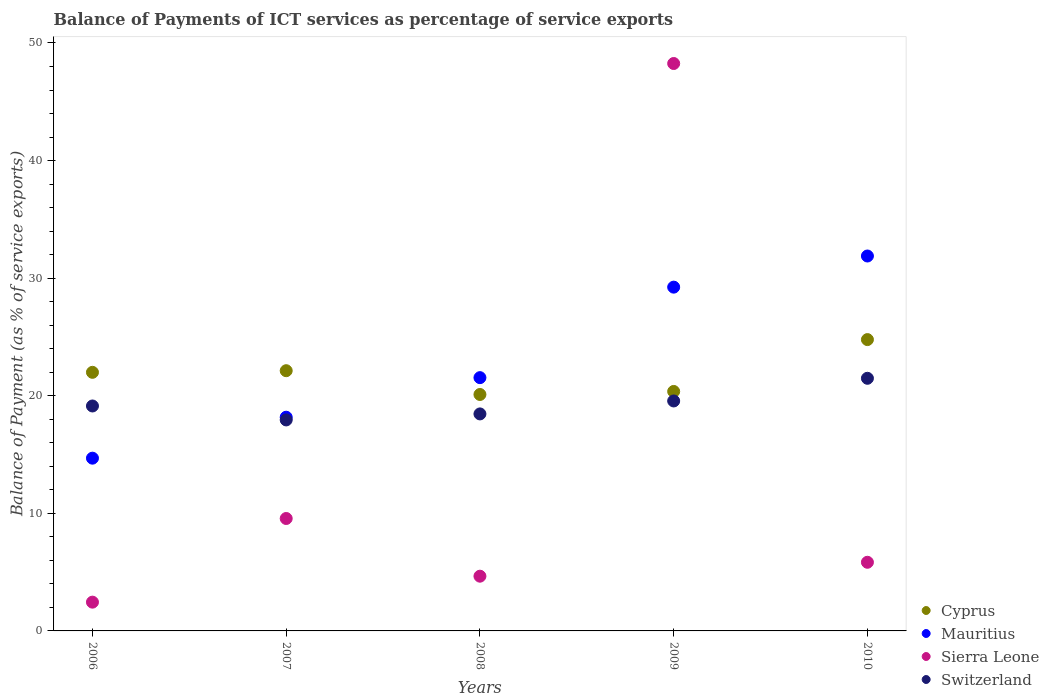What is the balance of payments of ICT services in Cyprus in 2009?
Provide a short and direct response. 20.37. Across all years, what is the maximum balance of payments of ICT services in Mauritius?
Your answer should be compact. 31.88. Across all years, what is the minimum balance of payments of ICT services in Mauritius?
Provide a succinct answer. 14.69. In which year was the balance of payments of ICT services in Switzerland maximum?
Your answer should be compact. 2010. What is the total balance of payments of ICT services in Cyprus in the graph?
Provide a succinct answer. 109.37. What is the difference between the balance of payments of ICT services in Cyprus in 2006 and that in 2010?
Ensure brevity in your answer.  -2.78. What is the difference between the balance of payments of ICT services in Switzerland in 2007 and the balance of payments of ICT services in Cyprus in 2010?
Offer a very short reply. -6.83. What is the average balance of payments of ICT services in Switzerland per year?
Offer a very short reply. 19.31. In the year 2008, what is the difference between the balance of payments of ICT services in Cyprus and balance of payments of ICT services in Mauritius?
Offer a terse response. -1.43. What is the ratio of the balance of payments of ICT services in Cyprus in 2006 to that in 2010?
Offer a terse response. 0.89. What is the difference between the highest and the second highest balance of payments of ICT services in Sierra Leone?
Make the answer very short. 38.69. What is the difference between the highest and the lowest balance of payments of ICT services in Mauritius?
Offer a very short reply. 17.19. In how many years, is the balance of payments of ICT services in Mauritius greater than the average balance of payments of ICT services in Mauritius taken over all years?
Your answer should be very brief. 2. Is the sum of the balance of payments of ICT services in Cyprus in 2007 and 2010 greater than the maximum balance of payments of ICT services in Sierra Leone across all years?
Offer a terse response. No. Is it the case that in every year, the sum of the balance of payments of ICT services in Switzerland and balance of payments of ICT services in Sierra Leone  is greater than the sum of balance of payments of ICT services in Cyprus and balance of payments of ICT services in Mauritius?
Make the answer very short. No. Is it the case that in every year, the sum of the balance of payments of ICT services in Switzerland and balance of payments of ICT services in Cyprus  is greater than the balance of payments of ICT services in Mauritius?
Provide a short and direct response. Yes. Is the balance of payments of ICT services in Cyprus strictly greater than the balance of payments of ICT services in Mauritius over the years?
Keep it short and to the point. No. How many years are there in the graph?
Give a very brief answer. 5. What is the difference between two consecutive major ticks on the Y-axis?
Keep it short and to the point. 10. Does the graph contain any zero values?
Your answer should be compact. No. Where does the legend appear in the graph?
Your answer should be very brief. Bottom right. What is the title of the graph?
Your answer should be compact. Balance of Payments of ICT services as percentage of service exports. Does "St. Lucia" appear as one of the legend labels in the graph?
Ensure brevity in your answer.  No. What is the label or title of the Y-axis?
Your answer should be very brief. Balance of Payment (as % of service exports). What is the Balance of Payment (as % of service exports) of Cyprus in 2006?
Your response must be concise. 21.99. What is the Balance of Payment (as % of service exports) of Mauritius in 2006?
Provide a succinct answer. 14.69. What is the Balance of Payment (as % of service exports) of Sierra Leone in 2006?
Provide a short and direct response. 2.45. What is the Balance of Payment (as % of service exports) of Switzerland in 2006?
Your answer should be very brief. 19.13. What is the Balance of Payment (as % of service exports) of Cyprus in 2007?
Provide a short and direct response. 22.13. What is the Balance of Payment (as % of service exports) in Mauritius in 2007?
Make the answer very short. 18.17. What is the Balance of Payment (as % of service exports) of Sierra Leone in 2007?
Make the answer very short. 9.56. What is the Balance of Payment (as % of service exports) in Switzerland in 2007?
Provide a succinct answer. 17.94. What is the Balance of Payment (as % of service exports) in Cyprus in 2008?
Offer a terse response. 20.11. What is the Balance of Payment (as % of service exports) in Mauritius in 2008?
Your response must be concise. 21.54. What is the Balance of Payment (as % of service exports) of Sierra Leone in 2008?
Offer a very short reply. 4.65. What is the Balance of Payment (as % of service exports) in Switzerland in 2008?
Give a very brief answer. 18.46. What is the Balance of Payment (as % of service exports) of Cyprus in 2009?
Your answer should be compact. 20.37. What is the Balance of Payment (as % of service exports) in Mauritius in 2009?
Your answer should be compact. 29.24. What is the Balance of Payment (as % of service exports) in Sierra Leone in 2009?
Keep it short and to the point. 48.26. What is the Balance of Payment (as % of service exports) of Switzerland in 2009?
Offer a terse response. 19.56. What is the Balance of Payment (as % of service exports) in Cyprus in 2010?
Keep it short and to the point. 24.78. What is the Balance of Payment (as % of service exports) of Mauritius in 2010?
Your answer should be very brief. 31.88. What is the Balance of Payment (as % of service exports) in Sierra Leone in 2010?
Make the answer very short. 5.84. What is the Balance of Payment (as % of service exports) of Switzerland in 2010?
Offer a terse response. 21.48. Across all years, what is the maximum Balance of Payment (as % of service exports) of Cyprus?
Your answer should be very brief. 24.78. Across all years, what is the maximum Balance of Payment (as % of service exports) in Mauritius?
Your answer should be compact. 31.88. Across all years, what is the maximum Balance of Payment (as % of service exports) in Sierra Leone?
Keep it short and to the point. 48.26. Across all years, what is the maximum Balance of Payment (as % of service exports) of Switzerland?
Make the answer very short. 21.48. Across all years, what is the minimum Balance of Payment (as % of service exports) in Cyprus?
Make the answer very short. 20.11. Across all years, what is the minimum Balance of Payment (as % of service exports) in Mauritius?
Provide a succinct answer. 14.69. Across all years, what is the minimum Balance of Payment (as % of service exports) in Sierra Leone?
Make the answer very short. 2.45. Across all years, what is the minimum Balance of Payment (as % of service exports) in Switzerland?
Your response must be concise. 17.94. What is the total Balance of Payment (as % of service exports) in Cyprus in the graph?
Give a very brief answer. 109.37. What is the total Balance of Payment (as % of service exports) in Mauritius in the graph?
Keep it short and to the point. 115.53. What is the total Balance of Payment (as % of service exports) of Sierra Leone in the graph?
Make the answer very short. 70.76. What is the total Balance of Payment (as % of service exports) of Switzerland in the graph?
Your answer should be compact. 96.57. What is the difference between the Balance of Payment (as % of service exports) of Cyprus in 2006 and that in 2007?
Offer a terse response. -0.14. What is the difference between the Balance of Payment (as % of service exports) of Mauritius in 2006 and that in 2007?
Offer a very short reply. -3.48. What is the difference between the Balance of Payment (as % of service exports) in Sierra Leone in 2006 and that in 2007?
Your answer should be very brief. -7.11. What is the difference between the Balance of Payment (as % of service exports) of Switzerland in 2006 and that in 2007?
Make the answer very short. 1.19. What is the difference between the Balance of Payment (as % of service exports) in Cyprus in 2006 and that in 2008?
Ensure brevity in your answer.  1.88. What is the difference between the Balance of Payment (as % of service exports) in Mauritius in 2006 and that in 2008?
Offer a very short reply. -6.85. What is the difference between the Balance of Payment (as % of service exports) of Sierra Leone in 2006 and that in 2008?
Give a very brief answer. -2.21. What is the difference between the Balance of Payment (as % of service exports) of Switzerland in 2006 and that in 2008?
Give a very brief answer. 0.67. What is the difference between the Balance of Payment (as % of service exports) of Cyprus in 2006 and that in 2009?
Ensure brevity in your answer.  1.63. What is the difference between the Balance of Payment (as % of service exports) in Mauritius in 2006 and that in 2009?
Make the answer very short. -14.54. What is the difference between the Balance of Payment (as % of service exports) of Sierra Leone in 2006 and that in 2009?
Your response must be concise. -45.81. What is the difference between the Balance of Payment (as % of service exports) in Switzerland in 2006 and that in 2009?
Your answer should be very brief. -0.43. What is the difference between the Balance of Payment (as % of service exports) in Cyprus in 2006 and that in 2010?
Your answer should be compact. -2.78. What is the difference between the Balance of Payment (as % of service exports) of Mauritius in 2006 and that in 2010?
Your answer should be compact. -17.19. What is the difference between the Balance of Payment (as % of service exports) of Sierra Leone in 2006 and that in 2010?
Your answer should be compact. -3.39. What is the difference between the Balance of Payment (as % of service exports) of Switzerland in 2006 and that in 2010?
Offer a very short reply. -2.36. What is the difference between the Balance of Payment (as % of service exports) of Cyprus in 2007 and that in 2008?
Offer a terse response. 2.02. What is the difference between the Balance of Payment (as % of service exports) in Mauritius in 2007 and that in 2008?
Offer a terse response. -3.37. What is the difference between the Balance of Payment (as % of service exports) in Sierra Leone in 2007 and that in 2008?
Make the answer very short. 4.91. What is the difference between the Balance of Payment (as % of service exports) in Switzerland in 2007 and that in 2008?
Offer a very short reply. -0.51. What is the difference between the Balance of Payment (as % of service exports) in Cyprus in 2007 and that in 2009?
Your answer should be compact. 1.76. What is the difference between the Balance of Payment (as % of service exports) of Mauritius in 2007 and that in 2009?
Provide a succinct answer. -11.06. What is the difference between the Balance of Payment (as % of service exports) in Sierra Leone in 2007 and that in 2009?
Offer a very short reply. -38.69. What is the difference between the Balance of Payment (as % of service exports) in Switzerland in 2007 and that in 2009?
Make the answer very short. -1.61. What is the difference between the Balance of Payment (as % of service exports) of Cyprus in 2007 and that in 2010?
Keep it short and to the point. -2.65. What is the difference between the Balance of Payment (as % of service exports) in Mauritius in 2007 and that in 2010?
Offer a terse response. -13.71. What is the difference between the Balance of Payment (as % of service exports) of Sierra Leone in 2007 and that in 2010?
Provide a succinct answer. 3.72. What is the difference between the Balance of Payment (as % of service exports) of Switzerland in 2007 and that in 2010?
Your response must be concise. -3.54. What is the difference between the Balance of Payment (as % of service exports) in Cyprus in 2008 and that in 2009?
Ensure brevity in your answer.  -0.26. What is the difference between the Balance of Payment (as % of service exports) in Mauritius in 2008 and that in 2009?
Your response must be concise. -7.7. What is the difference between the Balance of Payment (as % of service exports) of Sierra Leone in 2008 and that in 2009?
Provide a succinct answer. -43.6. What is the difference between the Balance of Payment (as % of service exports) of Switzerland in 2008 and that in 2009?
Provide a succinct answer. -1.1. What is the difference between the Balance of Payment (as % of service exports) of Cyprus in 2008 and that in 2010?
Offer a terse response. -4.67. What is the difference between the Balance of Payment (as % of service exports) in Mauritius in 2008 and that in 2010?
Your answer should be compact. -10.34. What is the difference between the Balance of Payment (as % of service exports) of Sierra Leone in 2008 and that in 2010?
Offer a very short reply. -1.18. What is the difference between the Balance of Payment (as % of service exports) of Switzerland in 2008 and that in 2010?
Make the answer very short. -3.03. What is the difference between the Balance of Payment (as % of service exports) of Cyprus in 2009 and that in 2010?
Provide a short and direct response. -4.41. What is the difference between the Balance of Payment (as % of service exports) in Mauritius in 2009 and that in 2010?
Provide a short and direct response. -2.65. What is the difference between the Balance of Payment (as % of service exports) of Sierra Leone in 2009 and that in 2010?
Offer a terse response. 42.42. What is the difference between the Balance of Payment (as % of service exports) of Switzerland in 2009 and that in 2010?
Your answer should be very brief. -1.93. What is the difference between the Balance of Payment (as % of service exports) of Cyprus in 2006 and the Balance of Payment (as % of service exports) of Mauritius in 2007?
Offer a very short reply. 3.82. What is the difference between the Balance of Payment (as % of service exports) of Cyprus in 2006 and the Balance of Payment (as % of service exports) of Sierra Leone in 2007?
Make the answer very short. 12.43. What is the difference between the Balance of Payment (as % of service exports) in Cyprus in 2006 and the Balance of Payment (as % of service exports) in Switzerland in 2007?
Offer a very short reply. 4.05. What is the difference between the Balance of Payment (as % of service exports) of Mauritius in 2006 and the Balance of Payment (as % of service exports) of Sierra Leone in 2007?
Give a very brief answer. 5.13. What is the difference between the Balance of Payment (as % of service exports) of Mauritius in 2006 and the Balance of Payment (as % of service exports) of Switzerland in 2007?
Keep it short and to the point. -3.25. What is the difference between the Balance of Payment (as % of service exports) in Sierra Leone in 2006 and the Balance of Payment (as % of service exports) in Switzerland in 2007?
Your response must be concise. -15.5. What is the difference between the Balance of Payment (as % of service exports) in Cyprus in 2006 and the Balance of Payment (as % of service exports) in Mauritius in 2008?
Your answer should be compact. 0.45. What is the difference between the Balance of Payment (as % of service exports) of Cyprus in 2006 and the Balance of Payment (as % of service exports) of Sierra Leone in 2008?
Your answer should be compact. 17.34. What is the difference between the Balance of Payment (as % of service exports) of Cyprus in 2006 and the Balance of Payment (as % of service exports) of Switzerland in 2008?
Your answer should be very brief. 3.54. What is the difference between the Balance of Payment (as % of service exports) in Mauritius in 2006 and the Balance of Payment (as % of service exports) in Sierra Leone in 2008?
Keep it short and to the point. 10.04. What is the difference between the Balance of Payment (as % of service exports) in Mauritius in 2006 and the Balance of Payment (as % of service exports) in Switzerland in 2008?
Offer a terse response. -3.76. What is the difference between the Balance of Payment (as % of service exports) of Sierra Leone in 2006 and the Balance of Payment (as % of service exports) of Switzerland in 2008?
Your answer should be very brief. -16.01. What is the difference between the Balance of Payment (as % of service exports) in Cyprus in 2006 and the Balance of Payment (as % of service exports) in Mauritius in 2009?
Ensure brevity in your answer.  -7.24. What is the difference between the Balance of Payment (as % of service exports) in Cyprus in 2006 and the Balance of Payment (as % of service exports) in Sierra Leone in 2009?
Offer a very short reply. -26.26. What is the difference between the Balance of Payment (as % of service exports) in Cyprus in 2006 and the Balance of Payment (as % of service exports) in Switzerland in 2009?
Provide a succinct answer. 2.43. What is the difference between the Balance of Payment (as % of service exports) of Mauritius in 2006 and the Balance of Payment (as % of service exports) of Sierra Leone in 2009?
Offer a terse response. -33.56. What is the difference between the Balance of Payment (as % of service exports) in Mauritius in 2006 and the Balance of Payment (as % of service exports) in Switzerland in 2009?
Your answer should be compact. -4.87. What is the difference between the Balance of Payment (as % of service exports) of Sierra Leone in 2006 and the Balance of Payment (as % of service exports) of Switzerland in 2009?
Your response must be concise. -17.11. What is the difference between the Balance of Payment (as % of service exports) of Cyprus in 2006 and the Balance of Payment (as % of service exports) of Mauritius in 2010?
Offer a terse response. -9.89. What is the difference between the Balance of Payment (as % of service exports) of Cyprus in 2006 and the Balance of Payment (as % of service exports) of Sierra Leone in 2010?
Provide a short and direct response. 16.15. What is the difference between the Balance of Payment (as % of service exports) of Cyprus in 2006 and the Balance of Payment (as % of service exports) of Switzerland in 2010?
Your response must be concise. 0.51. What is the difference between the Balance of Payment (as % of service exports) in Mauritius in 2006 and the Balance of Payment (as % of service exports) in Sierra Leone in 2010?
Ensure brevity in your answer.  8.85. What is the difference between the Balance of Payment (as % of service exports) in Mauritius in 2006 and the Balance of Payment (as % of service exports) in Switzerland in 2010?
Make the answer very short. -6.79. What is the difference between the Balance of Payment (as % of service exports) of Sierra Leone in 2006 and the Balance of Payment (as % of service exports) of Switzerland in 2010?
Your response must be concise. -19.04. What is the difference between the Balance of Payment (as % of service exports) of Cyprus in 2007 and the Balance of Payment (as % of service exports) of Mauritius in 2008?
Your answer should be very brief. 0.59. What is the difference between the Balance of Payment (as % of service exports) in Cyprus in 2007 and the Balance of Payment (as % of service exports) in Sierra Leone in 2008?
Your response must be concise. 17.48. What is the difference between the Balance of Payment (as % of service exports) of Cyprus in 2007 and the Balance of Payment (as % of service exports) of Switzerland in 2008?
Give a very brief answer. 3.67. What is the difference between the Balance of Payment (as % of service exports) in Mauritius in 2007 and the Balance of Payment (as % of service exports) in Sierra Leone in 2008?
Give a very brief answer. 13.52. What is the difference between the Balance of Payment (as % of service exports) of Mauritius in 2007 and the Balance of Payment (as % of service exports) of Switzerland in 2008?
Offer a terse response. -0.28. What is the difference between the Balance of Payment (as % of service exports) in Sierra Leone in 2007 and the Balance of Payment (as % of service exports) in Switzerland in 2008?
Ensure brevity in your answer.  -8.89. What is the difference between the Balance of Payment (as % of service exports) in Cyprus in 2007 and the Balance of Payment (as % of service exports) in Mauritius in 2009?
Ensure brevity in your answer.  -7.11. What is the difference between the Balance of Payment (as % of service exports) of Cyprus in 2007 and the Balance of Payment (as % of service exports) of Sierra Leone in 2009?
Make the answer very short. -26.13. What is the difference between the Balance of Payment (as % of service exports) in Cyprus in 2007 and the Balance of Payment (as % of service exports) in Switzerland in 2009?
Make the answer very short. 2.57. What is the difference between the Balance of Payment (as % of service exports) in Mauritius in 2007 and the Balance of Payment (as % of service exports) in Sierra Leone in 2009?
Ensure brevity in your answer.  -30.08. What is the difference between the Balance of Payment (as % of service exports) in Mauritius in 2007 and the Balance of Payment (as % of service exports) in Switzerland in 2009?
Your answer should be compact. -1.38. What is the difference between the Balance of Payment (as % of service exports) of Sierra Leone in 2007 and the Balance of Payment (as % of service exports) of Switzerland in 2009?
Make the answer very short. -10. What is the difference between the Balance of Payment (as % of service exports) in Cyprus in 2007 and the Balance of Payment (as % of service exports) in Mauritius in 2010?
Offer a terse response. -9.75. What is the difference between the Balance of Payment (as % of service exports) of Cyprus in 2007 and the Balance of Payment (as % of service exports) of Sierra Leone in 2010?
Offer a very short reply. 16.29. What is the difference between the Balance of Payment (as % of service exports) of Cyprus in 2007 and the Balance of Payment (as % of service exports) of Switzerland in 2010?
Give a very brief answer. 0.65. What is the difference between the Balance of Payment (as % of service exports) in Mauritius in 2007 and the Balance of Payment (as % of service exports) in Sierra Leone in 2010?
Ensure brevity in your answer.  12.34. What is the difference between the Balance of Payment (as % of service exports) of Mauritius in 2007 and the Balance of Payment (as % of service exports) of Switzerland in 2010?
Your answer should be very brief. -3.31. What is the difference between the Balance of Payment (as % of service exports) in Sierra Leone in 2007 and the Balance of Payment (as % of service exports) in Switzerland in 2010?
Provide a succinct answer. -11.92. What is the difference between the Balance of Payment (as % of service exports) of Cyprus in 2008 and the Balance of Payment (as % of service exports) of Mauritius in 2009?
Provide a succinct answer. -9.13. What is the difference between the Balance of Payment (as % of service exports) of Cyprus in 2008 and the Balance of Payment (as % of service exports) of Sierra Leone in 2009?
Make the answer very short. -28.15. What is the difference between the Balance of Payment (as % of service exports) of Cyprus in 2008 and the Balance of Payment (as % of service exports) of Switzerland in 2009?
Provide a succinct answer. 0.55. What is the difference between the Balance of Payment (as % of service exports) in Mauritius in 2008 and the Balance of Payment (as % of service exports) in Sierra Leone in 2009?
Make the answer very short. -26.72. What is the difference between the Balance of Payment (as % of service exports) in Mauritius in 2008 and the Balance of Payment (as % of service exports) in Switzerland in 2009?
Provide a succinct answer. 1.98. What is the difference between the Balance of Payment (as % of service exports) of Sierra Leone in 2008 and the Balance of Payment (as % of service exports) of Switzerland in 2009?
Your response must be concise. -14.9. What is the difference between the Balance of Payment (as % of service exports) of Cyprus in 2008 and the Balance of Payment (as % of service exports) of Mauritius in 2010?
Provide a short and direct response. -11.78. What is the difference between the Balance of Payment (as % of service exports) in Cyprus in 2008 and the Balance of Payment (as % of service exports) in Sierra Leone in 2010?
Offer a very short reply. 14.27. What is the difference between the Balance of Payment (as % of service exports) in Cyprus in 2008 and the Balance of Payment (as % of service exports) in Switzerland in 2010?
Your answer should be compact. -1.38. What is the difference between the Balance of Payment (as % of service exports) of Mauritius in 2008 and the Balance of Payment (as % of service exports) of Sierra Leone in 2010?
Offer a terse response. 15.7. What is the difference between the Balance of Payment (as % of service exports) in Mauritius in 2008 and the Balance of Payment (as % of service exports) in Switzerland in 2010?
Offer a terse response. 0.05. What is the difference between the Balance of Payment (as % of service exports) of Sierra Leone in 2008 and the Balance of Payment (as % of service exports) of Switzerland in 2010?
Your answer should be very brief. -16.83. What is the difference between the Balance of Payment (as % of service exports) in Cyprus in 2009 and the Balance of Payment (as % of service exports) in Mauritius in 2010?
Offer a terse response. -11.52. What is the difference between the Balance of Payment (as % of service exports) of Cyprus in 2009 and the Balance of Payment (as % of service exports) of Sierra Leone in 2010?
Offer a very short reply. 14.53. What is the difference between the Balance of Payment (as % of service exports) of Cyprus in 2009 and the Balance of Payment (as % of service exports) of Switzerland in 2010?
Ensure brevity in your answer.  -1.12. What is the difference between the Balance of Payment (as % of service exports) in Mauritius in 2009 and the Balance of Payment (as % of service exports) in Sierra Leone in 2010?
Your answer should be very brief. 23.4. What is the difference between the Balance of Payment (as % of service exports) in Mauritius in 2009 and the Balance of Payment (as % of service exports) in Switzerland in 2010?
Keep it short and to the point. 7.75. What is the difference between the Balance of Payment (as % of service exports) in Sierra Leone in 2009 and the Balance of Payment (as % of service exports) in Switzerland in 2010?
Give a very brief answer. 26.77. What is the average Balance of Payment (as % of service exports) in Cyprus per year?
Your answer should be very brief. 21.87. What is the average Balance of Payment (as % of service exports) in Mauritius per year?
Make the answer very short. 23.11. What is the average Balance of Payment (as % of service exports) of Sierra Leone per year?
Offer a very short reply. 14.15. What is the average Balance of Payment (as % of service exports) in Switzerland per year?
Your answer should be very brief. 19.31. In the year 2006, what is the difference between the Balance of Payment (as % of service exports) in Cyprus and Balance of Payment (as % of service exports) in Mauritius?
Ensure brevity in your answer.  7.3. In the year 2006, what is the difference between the Balance of Payment (as % of service exports) of Cyprus and Balance of Payment (as % of service exports) of Sierra Leone?
Make the answer very short. 19.55. In the year 2006, what is the difference between the Balance of Payment (as % of service exports) of Cyprus and Balance of Payment (as % of service exports) of Switzerland?
Provide a succinct answer. 2.86. In the year 2006, what is the difference between the Balance of Payment (as % of service exports) in Mauritius and Balance of Payment (as % of service exports) in Sierra Leone?
Make the answer very short. 12.24. In the year 2006, what is the difference between the Balance of Payment (as % of service exports) of Mauritius and Balance of Payment (as % of service exports) of Switzerland?
Make the answer very short. -4.44. In the year 2006, what is the difference between the Balance of Payment (as % of service exports) of Sierra Leone and Balance of Payment (as % of service exports) of Switzerland?
Your answer should be compact. -16.68. In the year 2007, what is the difference between the Balance of Payment (as % of service exports) of Cyprus and Balance of Payment (as % of service exports) of Mauritius?
Your response must be concise. 3.96. In the year 2007, what is the difference between the Balance of Payment (as % of service exports) in Cyprus and Balance of Payment (as % of service exports) in Sierra Leone?
Keep it short and to the point. 12.57. In the year 2007, what is the difference between the Balance of Payment (as % of service exports) in Cyprus and Balance of Payment (as % of service exports) in Switzerland?
Make the answer very short. 4.19. In the year 2007, what is the difference between the Balance of Payment (as % of service exports) in Mauritius and Balance of Payment (as % of service exports) in Sierra Leone?
Offer a terse response. 8.61. In the year 2007, what is the difference between the Balance of Payment (as % of service exports) in Mauritius and Balance of Payment (as % of service exports) in Switzerland?
Give a very brief answer. 0.23. In the year 2007, what is the difference between the Balance of Payment (as % of service exports) in Sierra Leone and Balance of Payment (as % of service exports) in Switzerland?
Offer a terse response. -8.38. In the year 2008, what is the difference between the Balance of Payment (as % of service exports) of Cyprus and Balance of Payment (as % of service exports) of Mauritius?
Provide a succinct answer. -1.43. In the year 2008, what is the difference between the Balance of Payment (as % of service exports) of Cyprus and Balance of Payment (as % of service exports) of Sierra Leone?
Keep it short and to the point. 15.45. In the year 2008, what is the difference between the Balance of Payment (as % of service exports) of Cyprus and Balance of Payment (as % of service exports) of Switzerland?
Give a very brief answer. 1.65. In the year 2008, what is the difference between the Balance of Payment (as % of service exports) of Mauritius and Balance of Payment (as % of service exports) of Sierra Leone?
Offer a very short reply. 16.89. In the year 2008, what is the difference between the Balance of Payment (as % of service exports) in Mauritius and Balance of Payment (as % of service exports) in Switzerland?
Give a very brief answer. 3.08. In the year 2008, what is the difference between the Balance of Payment (as % of service exports) in Sierra Leone and Balance of Payment (as % of service exports) in Switzerland?
Ensure brevity in your answer.  -13.8. In the year 2009, what is the difference between the Balance of Payment (as % of service exports) in Cyprus and Balance of Payment (as % of service exports) in Mauritius?
Your response must be concise. -8.87. In the year 2009, what is the difference between the Balance of Payment (as % of service exports) in Cyprus and Balance of Payment (as % of service exports) in Sierra Leone?
Offer a very short reply. -27.89. In the year 2009, what is the difference between the Balance of Payment (as % of service exports) of Cyprus and Balance of Payment (as % of service exports) of Switzerland?
Make the answer very short. 0.81. In the year 2009, what is the difference between the Balance of Payment (as % of service exports) of Mauritius and Balance of Payment (as % of service exports) of Sierra Leone?
Keep it short and to the point. -19.02. In the year 2009, what is the difference between the Balance of Payment (as % of service exports) of Mauritius and Balance of Payment (as % of service exports) of Switzerland?
Your answer should be compact. 9.68. In the year 2009, what is the difference between the Balance of Payment (as % of service exports) of Sierra Leone and Balance of Payment (as % of service exports) of Switzerland?
Make the answer very short. 28.7. In the year 2010, what is the difference between the Balance of Payment (as % of service exports) of Cyprus and Balance of Payment (as % of service exports) of Mauritius?
Ensure brevity in your answer.  -7.11. In the year 2010, what is the difference between the Balance of Payment (as % of service exports) in Cyprus and Balance of Payment (as % of service exports) in Sierra Leone?
Your answer should be compact. 18.94. In the year 2010, what is the difference between the Balance of Payment (as % of service exports) of Cyprus and Balance of Payment (as % of service exports) of Switzerland?
Offer a terse response. 3.29. In the year 2010, what is the difference between the Balance of Payment (as % of service exports) of Mauritius and Balance of Payment (as % of service exports) of Sierra Leone?
Provide a short and direct response. 26.05. In the year 2010, what is the difference between the Balance of Payment (as % of service exports) in Mauritius and Balance of Payment (as % of service exports) in Switzerland?
Your response must be concise. 10.4. In the year 2010, what is the difference between the Balance of Payment (as % of service exports) in Sierra Leone and Balance of Payment (as % of service exports) in Switzerland?
Your answer should be very brief. -15.65. What is the ratio of the Balance of Payment (as % of service exports) in Cyprus in 2006 to that in 2007?
Provide a succinct answer. 0.99. What is the ratio of the Balance of Payment (as % of service exports) in Mauritius in 2006 to that in 2007?
Provide a short and direct response. 0.81. What is the ratio of the Balance of Payment (as % of service exports) of Sierra Leone in 2006 to that in 2007?
Give a very brief answer. 0.26. What is the ratio of the Balance of Payment (as % of service exports) of Switzerland in 2006 to that in 2007?
Offer a very short reply. 1.07. What is the ratio of the Balance of Payment (as % of service exports) of Cyprus in 2006 to that in 2008?
Offer a terse response. 1.09. What is the ratio of the Balance of Payment (as % of service exports) of Mauritius in 2006 to that in 2008?
Provide a short and direct response. 0.68. What is the ratio of the Balance of Payment (as % of service exports) in Sierra Leone in 2006 to that in 2008?
Your answer should be compact. 0.53. What is the ratio of the Balance of Payment (as % of service exports) in Switzerland in 2006 to that in 2008?
Offer a terse response. 1.04. What is the ratio of the Balance of Payment (as % of service exports) in Cyprus in 2006 to that in 2009?
Ensure brevity in your answer.  1.08. What is the ratio of the Balance of Payment (as % of service exports) in Mauritius in 2006 to that in 2009?
Your response must be concise. 0.5. What is the ratio of the Balance of Payment (as % of service exports) of Sierra Leone in 2006 to that in 2009?
Ensure brevity in your answer.  0.05. What is the ratio of the Balance of Payment (as % of service exports) of Switzerland in 2006 to that in 2009?
Offer a very short reply. 0.98. What is the ratio of the Balance of Payment (as % of service exports) of Cyprus in 2006 to that in 2010?
Your answer should be compact. 0.89. What is the ratio of the Balance of Payment (as % of service exports) in Mauritius in 2006 to that in 2010?
Provide a succinct answer. 0.46. What is the ratio of the Balance of Payment (as % of service exports) of Sierra Leone in 2006 to that in 2010?
Offer a terse response. 0.42. What is the ratio of the Balance of Payment (as % of service exports) of Switzerland in 2006 to that in 2010?
Provide a short and direct response. 0.89. What is the ratio of the Balance of Payment (as % of service exports) in Cyprus in 2007 to that in 2008?
Your response must be concise. 1.1. What is the ratio of the Balance of Payment (as % of service exports) in Mauritius in 2007 to that in 2008?
Your response must be concise. 0.84. What is the ratio of the Balance of Payment (as % of service exports) of Sierra Leone in 2007 to that in 2008?
Offer a very short reply. 2.05. What is the ratio of the Balance of Payment (as % of service exports) of Switzerland in 2007 to that in 2008?
Your answer should be very brief. 0.97. What is the ratio of the Balance of Payment (as % of service exports) of Cyprus in 2007 to that in 2009?
Your response must be concise. 1.09. What is the ratio of the Balance of Payment (as % of service exports) in Mauritius in 2007 to that in 2009?
Your answer should be compact. 0.62. What is the ratio of the Balance of Payment (as % of service exports) in Sierra Leone in 2007 to that in 2009?
Your answer should be very brief. 0.2. What is the ratio of the Balance of Payment (as % of service exports) of Switzerland in 2007 to that in 2009?
Provide a short and direct response. 0.92. What is the ratio of the Balance of Payment (as % of service exports) of Cyprus in 2007 to that in 2010?
Give a very brief answer. 0.89. What is the ratio of the Balance of Payment (as % of service exports) in Mauritius in 2007 to that in 2010?
Your answer should be very brief. 0.57. What is the ratio of the Balance of Payment (as % of service exports) of Sierra Leone in 2007 to that in 2010?
Give a very brief answer. 1.64. What is the ratio of the Balance of Payment (as % of service exports) in Switzerland in 2007 to that in 2010?
Provide a succinct answer. 0.84. What is the ratio of the Balance of Payment (as % of service exports) in Cyprus in 2008 to that in 2009?
Keep it short and to the point. 0.99. What is the ratio of the Balance of Payment (as % of service exports) of Mauritius in 2008 to that in 2009?
Your answer should be very brief. 0.74. What is the ratio of the Balance of Payment (as % of service exports) in Sierra Leone in 2008 to that in 2009?
Ensure brevity in your answer.  0.1. What is the ratio of the Balance of Payment (as % of service exports) in Switzerland in 2008 to that in 2009?
Give a very brief answer. 0.94. What is the ratio of the Balance of Payment (as % of service exports) of Cyprus in 2008 to that in 2010?
Offer a terse response. 0.81. What is the ratio of the Balance of Payment (as % of service exports) in Mauritius in 2008 to that in 2010?
Offer a terse response. 0.68. What is the ratio of the Balance of Payment (as % of service exports) of Sierra Leone in 2008 to that in 2010?
Make the answer very short. 0.8. What is the ratio of the Balance of Payment (as % of service exports) of Switzerland in 2008 to that in 2010?
Your response must be concise. 0.86. What is the ratio of the Balance of Payment (as % of service exports) in Cyprus in 2009 to that in 2010?
Ensure brevity in your answer.  0.82. What is the ratio of the Balance of Payment (as % of service exports) of Mauritius in 2009 to that in 2010?
Give a very brief answer. 0.92. What is the ratio of the Balance of Payment (as % of service exports) in Sierra Leone in 2009 to that in 2010?
Make the answer very short. 8.27. What is the ratio of the Balance of Payment (as % of service exports) of Switzerland in 2009 to that in 2010?
Your response must be concise. 0.91. What is the difference between the highest and the second highest Balance of Payment (as % of service exports) in Cyprus?
Offer a terse response. 2.65. What is the difference between the highest and the second highest Balance of Payment (as % of service exports) of Mauritius?
Provide a short and direct response. 2.65. What is the difference between the highest and the second highest Balance of Payment (as % of service exports) of Sierra Leone?
Give a very brief answer. 38.69. What is the difference between the highest and the second highest Balance of Payment (as % of service exports) of Switzerland?
Make the answer very short. 1.93. What is the difference between the highest and the lowest Balance of Payment (as % of service exports) of Cyprus?
Provide a succinct answer. 4.67. What is the difference between the highest and the lowest Balance of Payment (as % of service exports) of Mauritius?
Your response must be concise. 17.19. What is the difference between the highest and the lowest Balance of Payment (as % of service exports) in Sierra Leone?
Your answer should be very brief. 45.81. What is the difference between the highest and the lowest Balance of Payment (as % of service exports) of Switzerland?
Keep it short and to the point. 3.54. 